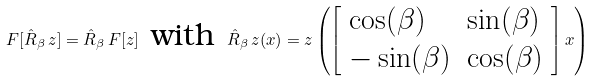<formula> <loc_0><loc_0><loc_500><loc_500>F [ \hat { R } _ { \beta } \, z ] = \hat { R } _ { \beta } \, F [ z ] \, \text { with } \, \hat { R } _ { \beta } \, z ( x ) = z \left ( { \left [ \begin{array} { l l } \cos ( \beta ) & \sin ( \beta ) \\ - \sin ( \beta ) & \cos ( \beta ) \end{array} \right ] } \, x \right )</formula> 